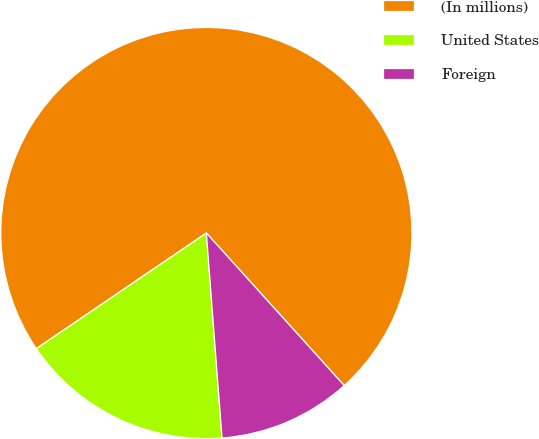<chart> <loc_0><loc_0><loc_500><loc_500><pie_chart><fcel>(In millions)<fcel>United States<fcel>Foreign<nl><fcel>72.81%<fcel>16.71%<fcel>10.48%<nl></chart> 